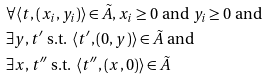Convert formula to latex. <formula><loc_0><loc_0><loc_500><loc_500>& \forall \langle t , ( x _ { i } , y _ { i } ) \rangle \in \tilde { A } , x _ { i } \geq 0 \text { and } y _ { i } \geq 0 \text { and } \\ & \exists y , t ^ { \prime } \text { s.t. } \langle t ^ { \prime } , ( 0 , y ) \rangle \in \tilde { A } \text { and } \\ & \exists x , t ^ { \prime \prime } \text { s.t. } \langle t ^ { \prime \prime } , ( x , 0 ) \rangle \in \tilde { A }</formula> 